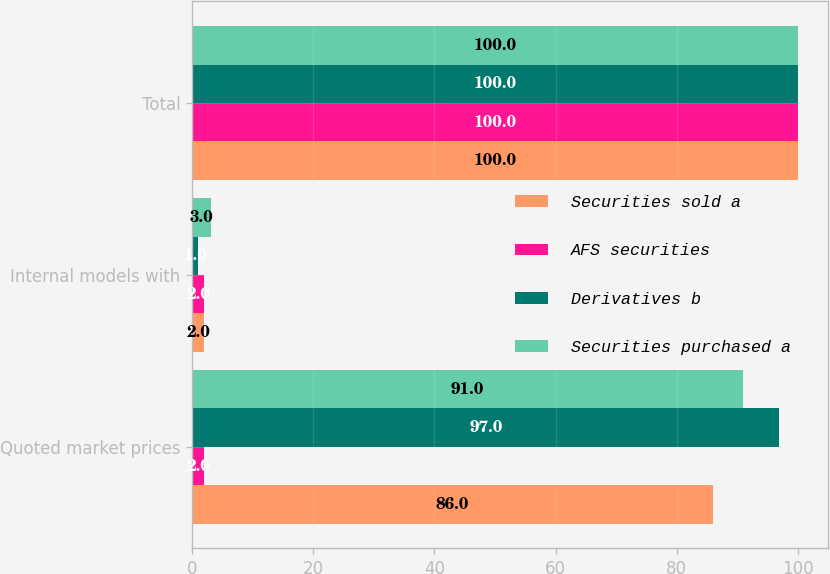Convert chart. <chart><loc_0><loc_0><loc_500><loc_500><stacked_bar_chart><ecel><fcel>Quoted market prices<fcel>Internal models with<fcel>Total<nl><fcel>Securities sold a<fcel>86<fcel>2<fcel>100<nl><fcel>AFS securities<fcel>2<fcel>2<fcel>100<nl><fcel>Derivatives b<fcel>97<fcel>1<fcel>100<nl><fcel>Securities purchased a<fcel>91<fcel>3<fcel>100<nl></chart> 